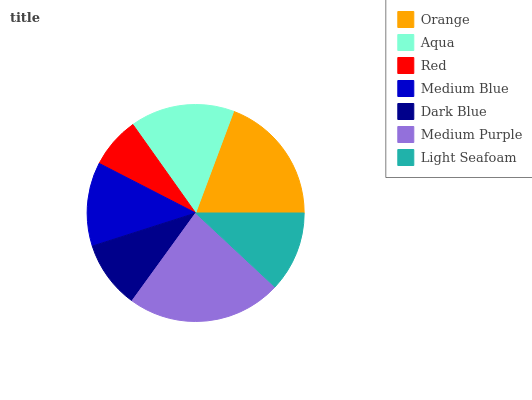Is Red the minimum?
Answer yes or no. Yes. Is Medium Purple the maximum?
Answer yes or no. Yes. Is Aqua the minimum?
Answer yes or no. No. Is Aqua the maximum?
Answer yes or no. No. Is Orange greater than Aqua?
Answer yes or no. Yes. Is Aqua less than Orange?
Answer yes or no. Yes. Is Aqua greater than Orange?
Answer yes or no. No. Is Orange less than Aqua?
Answer yes or no. No. Is Medium Blue the high median?
Answer yes or no. Yes. Is Medium Blue the low median?
Answer yes or no. Yes. Is Red the high median?
Answer yes or no. No. Is Light Seafoam the low median?
Answer yes or no. No. 